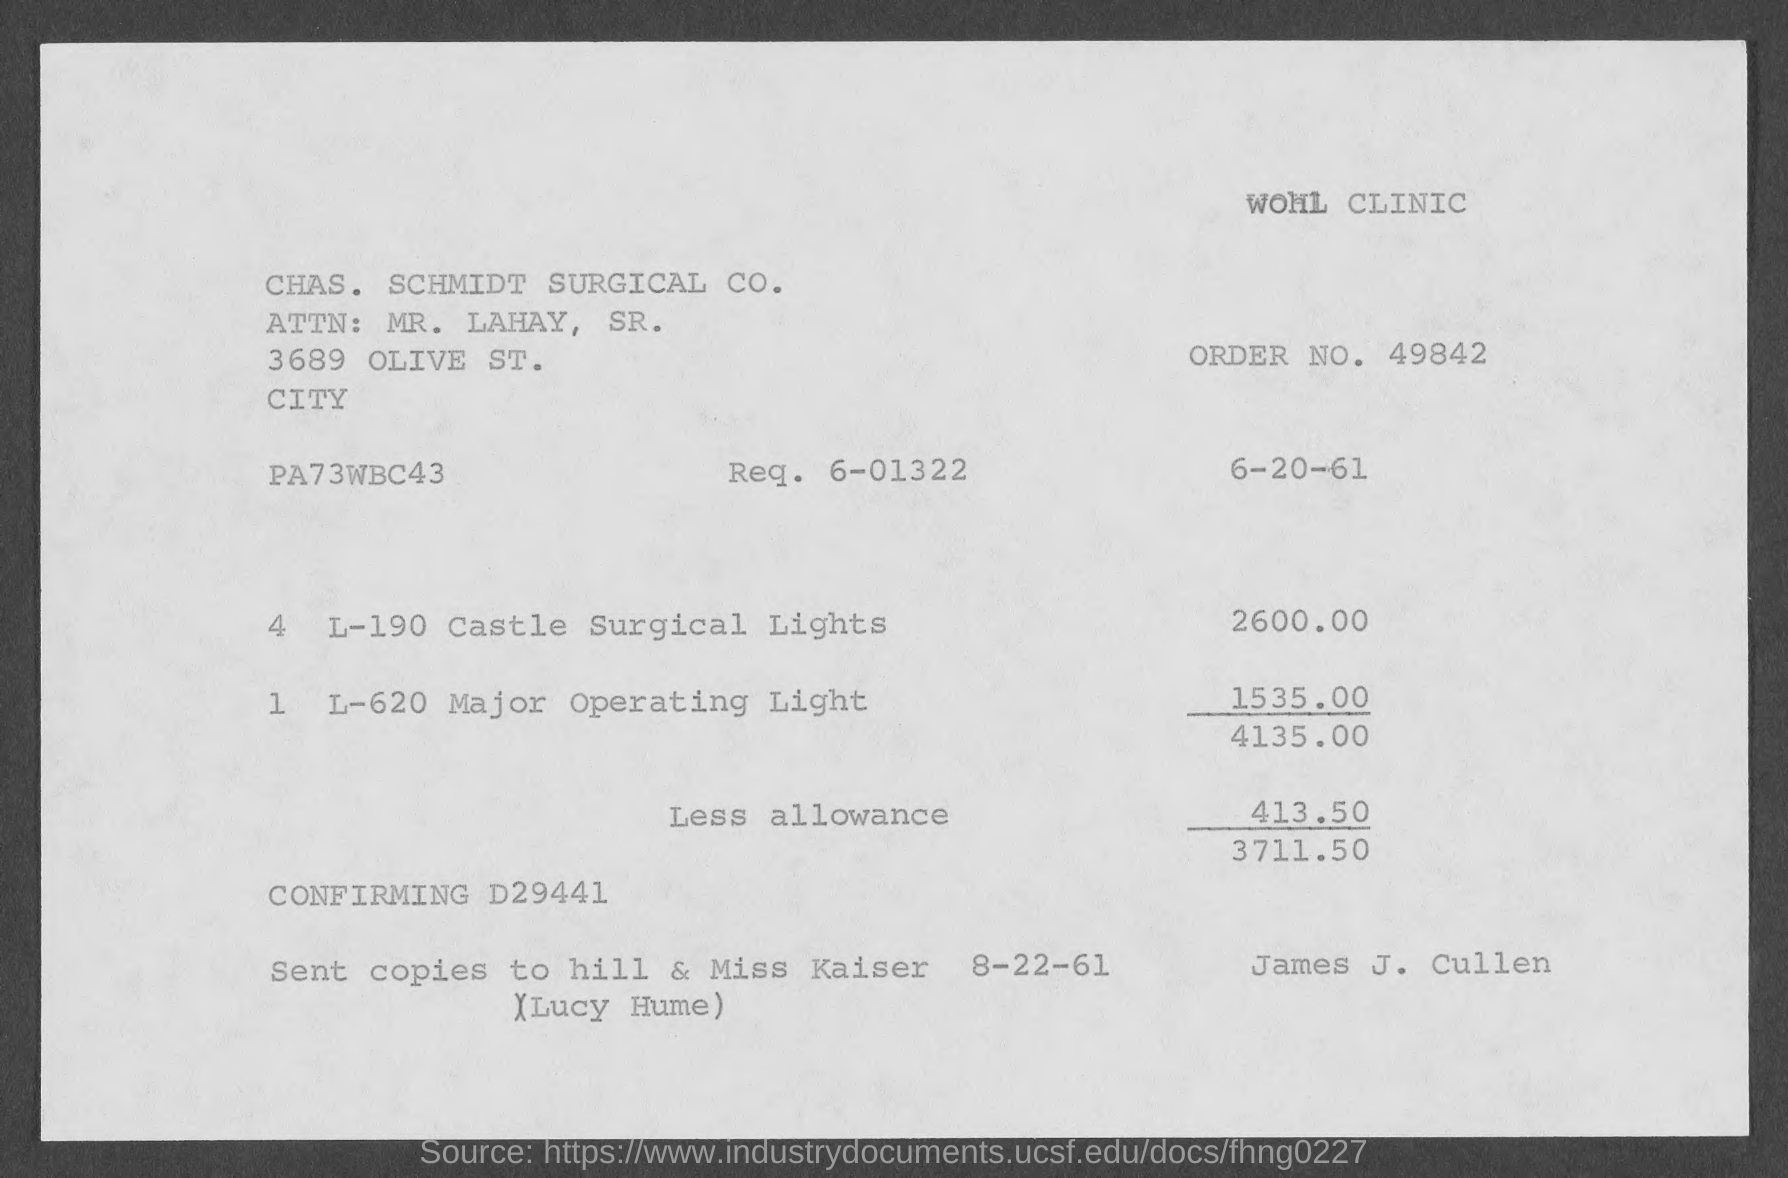What are the items listed on the invoice, and what are their individual prices? The invoice lists two items: '4 L-190 Castle Surgical Lights' priced at $2,600.00 and '1 L-620 Major Operating Light' priced at $1,535.00. These add up to a subtotal of $4,135.00 before the less allowance is applied. 